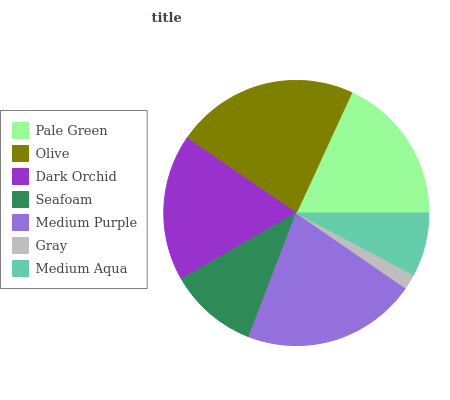Is Gray the minimum?
Answer yes or no. Yes. Is Olive the maximum?
Answer yes or no. Yes. Is Dark Orchid the minimum?
Answer yes or no. No. Is Dark Orchid the maximum?
Answer yes or no. No. Is Olive greater than Dark Orchid?
Answer yes or no. Yes. Is Dark Orchid less than Olive?
Answer yes or no. Yes. Is Dark Orchid greater than Olive?
Answer yes or no. No. Is Olive less than Dark Orchid?
Answer yes or no. No. Is Dark Orchid the high median?
Answer yes or no. Yes. Is Dark Orchid the low median?
Answer yes or no. Yes. Is Olive the high median?
Answer yes or no. No. Is Medium Aqua the low median?
Answer yes or no. No. 